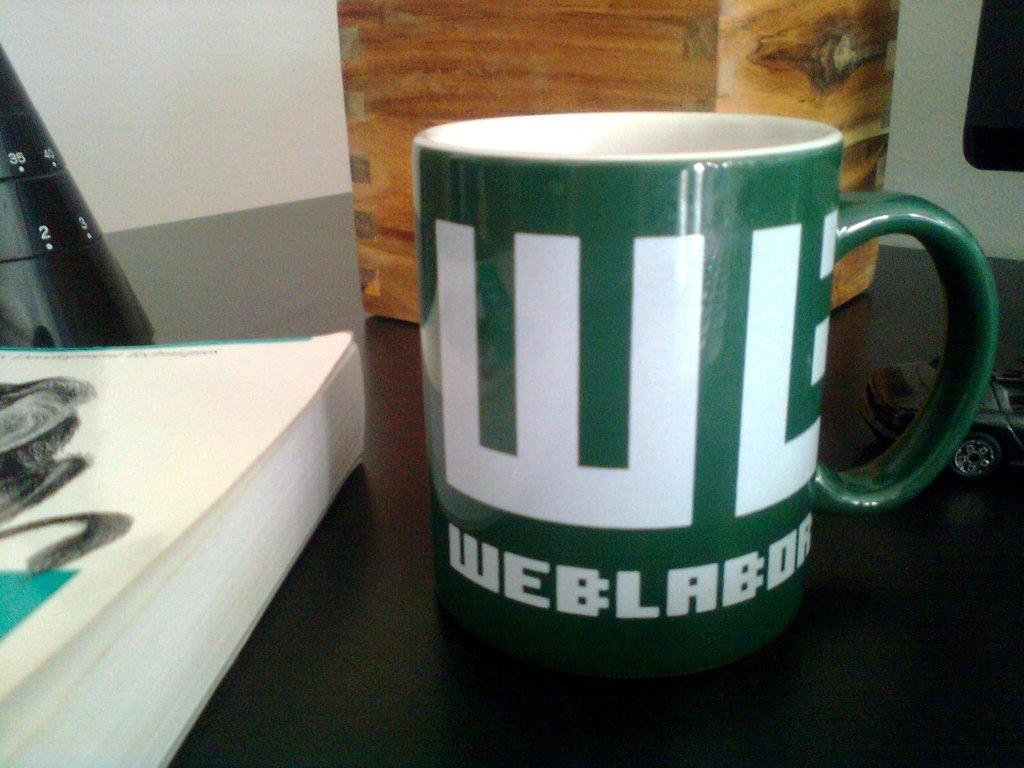<image>
Describe the image concisely. A green mug sits on a counter with the word Web written on it. 